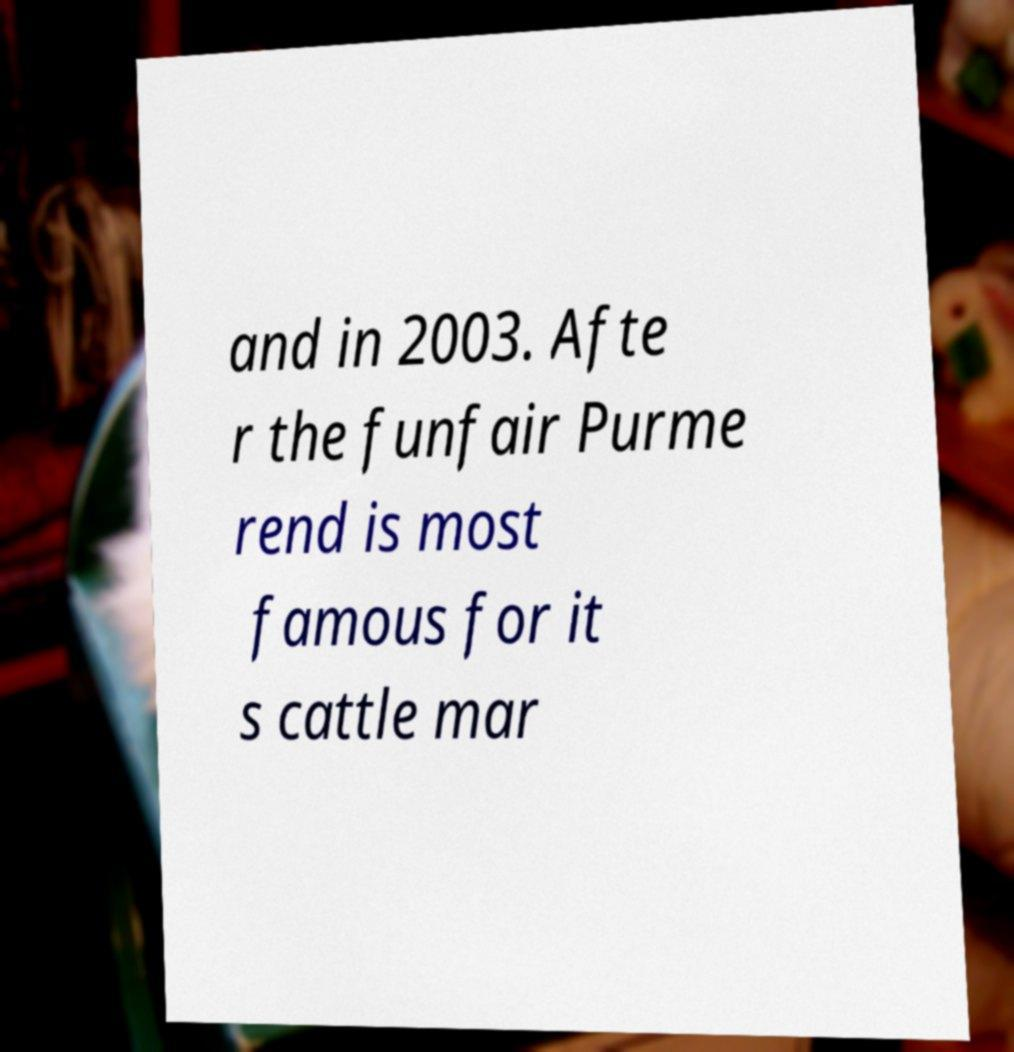I need the written content from this picture converted into text. Can you do that? and in 2003. Afte r the funfair Purme rend is most famous for it s cattle mar 